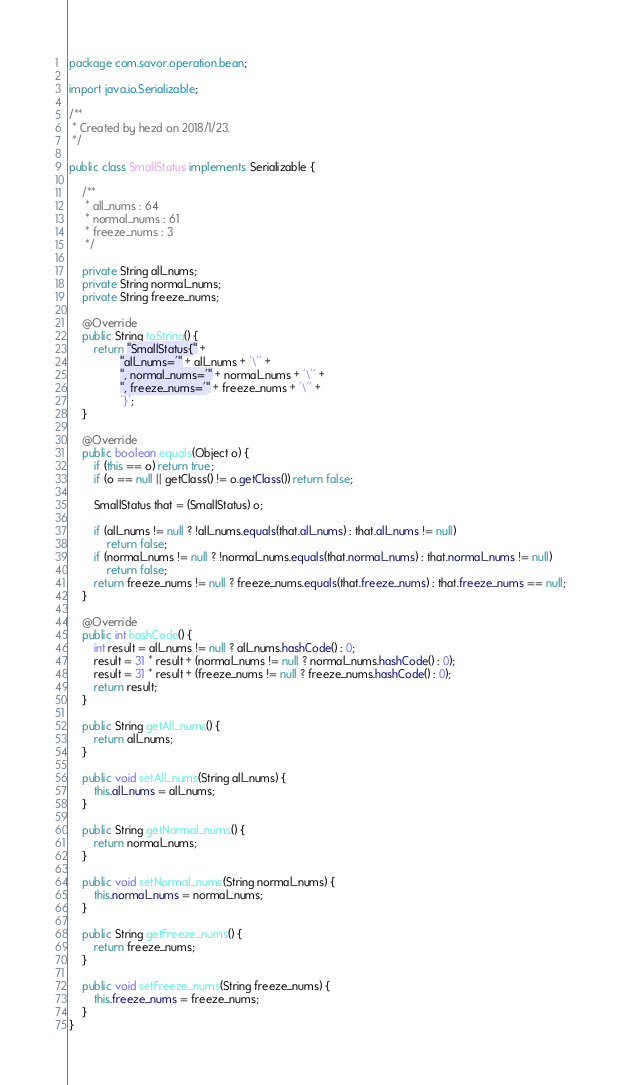Convert code to text. <code><loc_0><loc_0><loc_500><loc_500><_Java_>package com.savor.operation.bean;

import java.io.Serializable;

/**
 * Created by hezd on 2018/1/23.
 */

public class SmallStatus implements Serializable {

    /**
     * all_nums : 64
     * normal_nums : 61
     * freeze_nums : 3
     */

    private String all_nums;
    private String normal_nums;
    private String freeze_nums;

    @Override
    public String toString() {
        return "SmallStatus{" +
                "all_nums='" + all_nums + '\'' +
                ", normal_nums='" + normal_nums + '\'' +
                ", freeze_nums='" + freeze_nums + '\'' +
                '}';
    }

    @Override
    public boolean equals(Object o) {
        if (this == o) return true;
        if (o == null || getClass() != o.getClass()) return false;

        SmallStatus that = (SmallStatus) o;

        if (all_nums != null ? !all_nums.equals(that.all_nums) : that.all_nums != null)
            return false;
        if (normal_nums != null ? !normal_nums.equals(that.normal_nums) : that.normal_nums != null)
            return false;
        return freeze_nums != null ? freeze_nums.equals(that.freeze_nums) : that.freeze_nums == null;
    }

    @Override
    public int hashCode() {
        int result = all_nums != null ? all_nums.hashCode() : 0;
        result = 31 * result + (normal_nums != null ? normal_nums.hashCode() : 0);
        result = 31 * result + (freeze_nums != null ? freeze_nums.hashCode() : 0);
        return result;
    }

    public String getAll_nums() {
        return all_nums;
    }

    public void setAll_nums(String all_nums) {
        this.all_nums = all_nums;
    }

    public String getNormal_nums() {
        return normal_nums;
    }

    public void setNormal_nums(String normal_nums) {
        this.normal_nums = normal_nums;
    }

    public String getFreeze_nums() {
        return freeze_nums;
    }

    public void setFreeze_nums(String freeze_nums) {
        this.freeze_nums = freeze_nums;
    }
}
</code> 